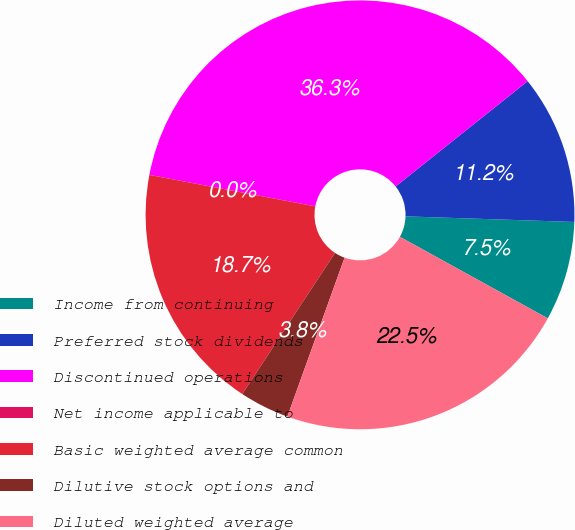Convert chart. <chart><loc_0><loc_0><loc_500><loc_500><pie_chart><fcel>Income from continuing<fcel>Preferred stock dividends<fcel>Discontinued operations<fcel>Net income applicable to<fcel>Basic weighted average common<fcel>Dilutive stock options and<fcel>Diluted weighted average<nl><fcel>7.49%<fcel>11.24%<fcel>36.3%<fcel>0.0%<fcel>18.73%<fcel>3.75%<fcel>22.48%<nl></chart> 